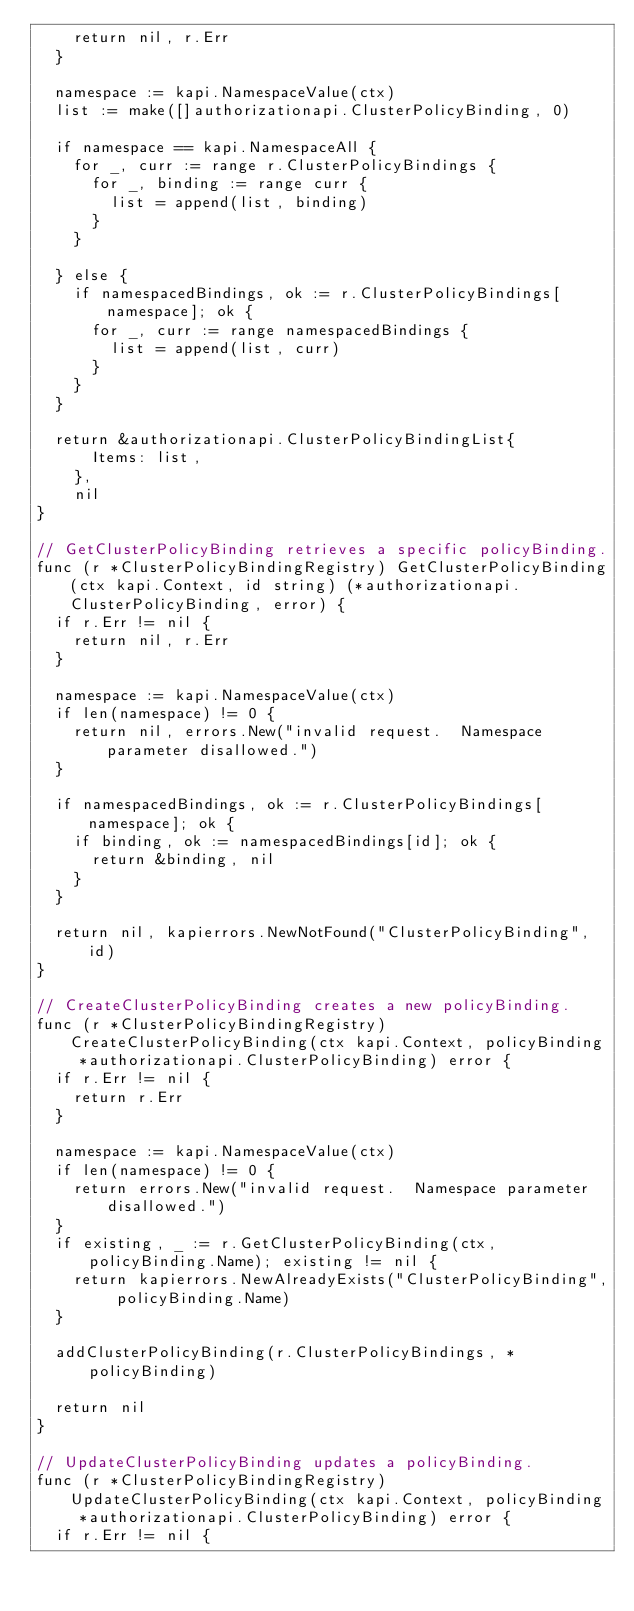Convert code to text. <code><loc_0><loc_0><loc_500><loc_500><_Go_>		return nil, r.Err
	}

	namespace := kapi.NamespaceValue(ctx)
	list := make([]authorizationapi.ClusterPolicyBinding, 0)

	if namespace == kapi.NamespaceAll {
		for _, curr := range r.ClusterPolicyBindings {
			for _, binding := range curr {
				list = append(list, binding)
			}
		}

	} else {
		if namespacedBindings, ok := r.ClusterPolicyBindings[namespace]; ok {
			for _, curr := range namespacedBindings {
				list = append(list, curr)
			}
		}
	}

	return &authorizationapi.ClusterPolicyBindingList{
			Items: list,
		},
		nil
}

// GetClusterPolicyBinding retrieves a specific policyBinding.
func (r *ClusterPolicyBindingRegistry) GetClusterPolicyBinding(ctx kapi.Context, id string) (*authorizationapi.ClusterPolicyBinding, error) {
	if r.Err != nil {
		return nil, r.Err
	}

	namespace := kapi.NamespaceValue(ctx)
	if len(namespace) != 0 {
		return nil, errors.New("invalid request.  Namespace parameter disallowed.")
	}

	if namespacedBindings, ok := r.ClusterPolicyBindings[namespace]; ok {
		if binding, ok := namespacedBindings[id]; ok {
			return &binding, nil
		}
	}

	return nil, kapierrors.NewNotFound("ClusterPolicyBinding", id)
}

// CreateClusterPolicyBinding creates a new policyBinding.
func (r *ClusterPolicyBindingRegistry) CreateClusterPolicyBinding(ctx kapi.Context, policyBinding *authorizationapi.ClusterPolicyBinding) error {
	if r.Err != nil {
		return r.Err
	}

	namespace := kapi.NamespaceValue(ctx)
	if len(namespace) != 0 {
		return errors.New("invalid request.  Namespace parameter disallowed.")
	}
	if existing, _ := r.GetClusterPolicyBinding(ctx, policyBinding.Name); existing != nil {
		return kapierrors.NewAlreadyExists("ClusterPolicyBinding", policyBinding.Name)
	}

	addClusterPolicyBinding(r.ClusterPolicyBindings, *policyBinding)

	return nil
}

// UpdateClusterPolicyBinding updates a policyBinding.
func (r *ClusterPolicyBindingRegistry) UpdateClusterPolicyBinding(ctx kapi.Context, policyBinding *authorizationapi.ClusterPolicyBinding) error {
	if r.Err != nil {</code> 